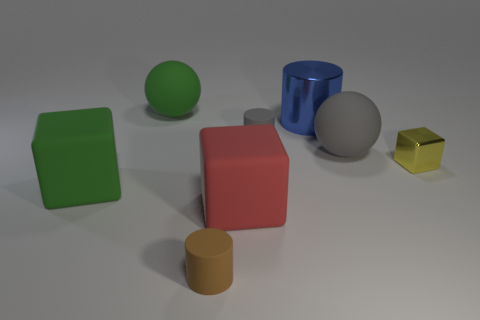Subtract all tiny cylinders. How many cylinders are left? 1 Subtract all red cubes. How many cubes are left? 2 Subtract 2 spheres. How many spheres are left? 0 Subtract all cylinders. How many objects are left? 5 Add 2 small matte objects. How many objects exist? 10 Subtract all cyan spheres. Subtract all purple cylinders. How many spheres are left? 2 Subtract all blue balls. How many blue blocks are left? 0 Subtract all big purple blocks. Subtract all tiny blocks. How many objects are left? 7 Add 4 metallic blocks. How many metallic blocks are left? 5 Add 1 small yellow blocks. How many small yellow blocks exist? 2 